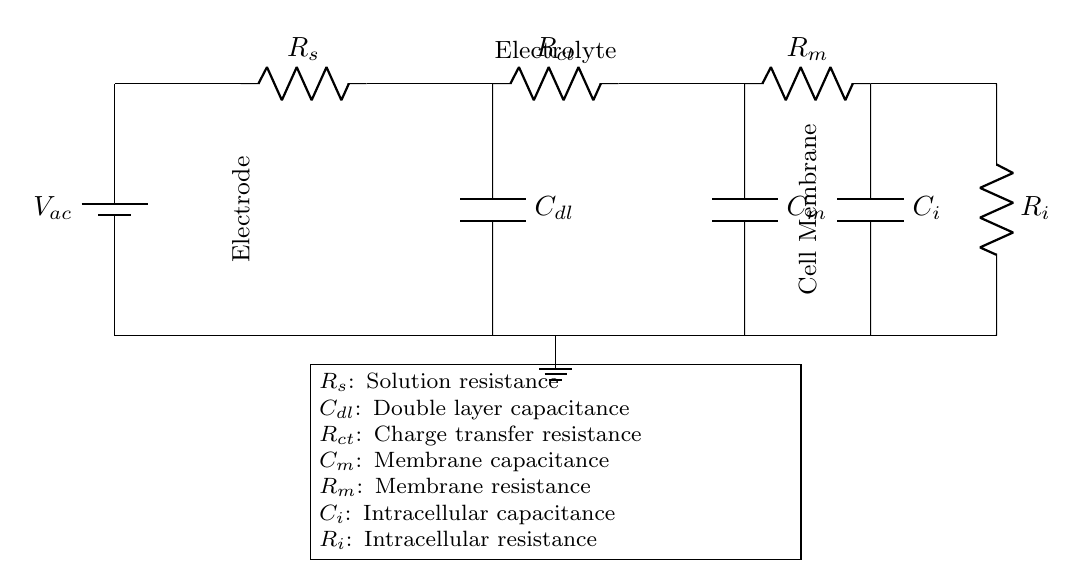What is the capacitance of the double layer? The capacitance of the double layer is represented as C sub dl in the circuit diagram.
Answer: C sub dl What is the resistance of the cell membrane? The resistance of the cell membrane is labeled as R sub m in the diagram.
Answer: R sub m How many resistors are present in this circuit? There are four resistors in total: R sub s, R sub ct, R sub m, and R sub i.
Answer: Four What does the symbol V sub ac represent? V sub ac is the alternating voltage source applied to the circuit, providing an input for the electrochemical analysis.
Answer: Alternating voltage What is the relationship between C sub m and R sub m in this circuit? C sub m and R sub m are elements of the equivalent circuit of the cell membrane, indicating how the membrane behaves electrochemically. Together, they define the time constant and influence the cell's impedance response.
Answer: Time constant What is the equivalent circuit element for the intracellular resistance? The intracellular resistance is represented as R sub i in the schematic.
Answer: R sub i What does the notation "ground" signify in this diagram? The ground notation indicates a reference point of zero potential in the circuit, ensuring all other voltages are measured with respect to this point.
Answer: Zero potential 